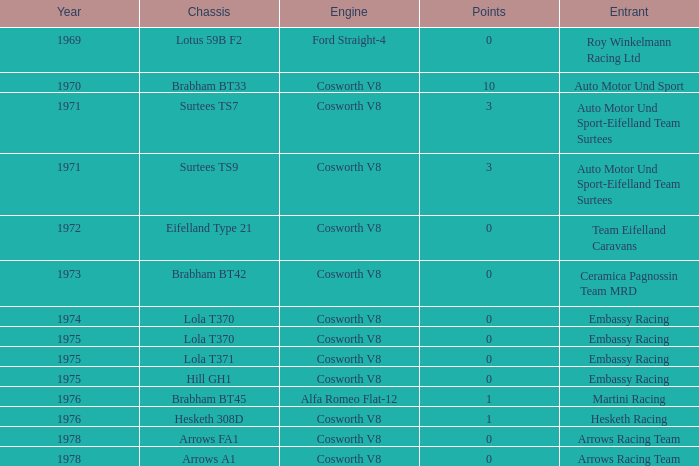Who was the entrant in 1971? Auto Motor Und Sport-Eifelland Team Surtees, Auto Motor Und Sport-Eifelland Team Surtees. 